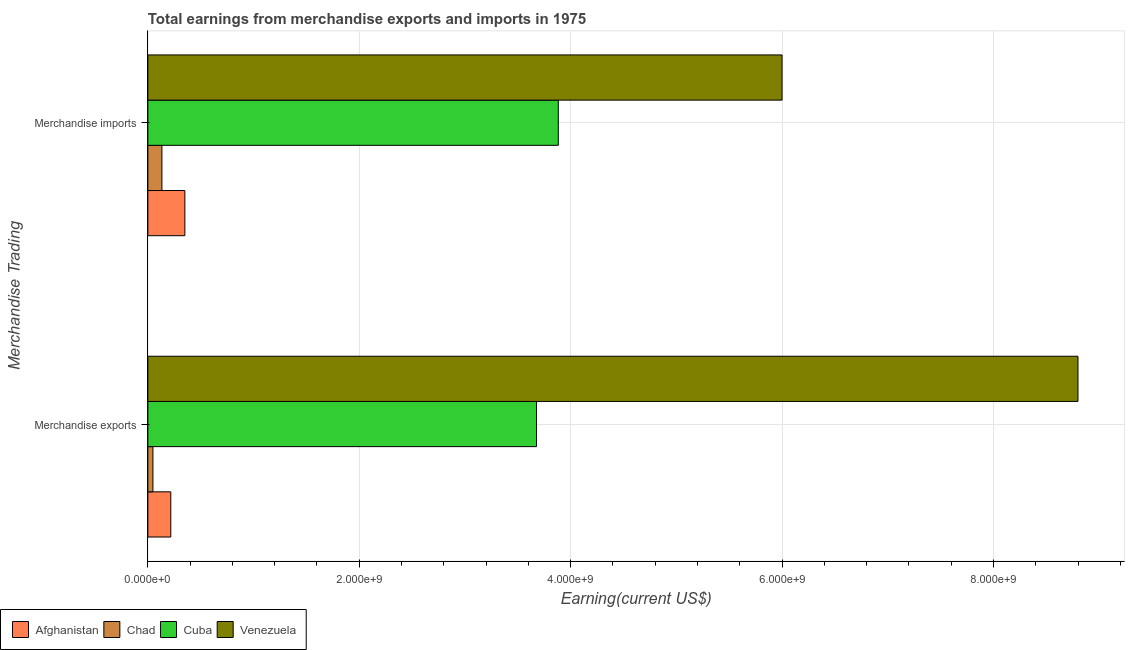Are the number of bars per tick equal to the number of legend labels?
Your response must be concise. Yes. What is the label of the 1st group of bars from the top?
Keep it short and to the point. Merchandise imports. What is the earnings from merchandise imports in Chad?
Provide a succinct answer. 1.33e+08. Across all countries, what is the maximum earnings from merchandise imports?
Your response must be concise. 6.00e+09. Across all countries, what is the minimum earnings from merchandise exports?
Your response must be concise. 4.78e+07. In which country was the earnings from merchandise imports maximum?
Give a very brief answer. Venezuela. In which country was the earnings from merchandise exports minimum?
Offer a terse response. Chad. What is the total earnings from merchandise imports in the graph?
Provide a succinct answer. 1.04e+1. What is the difference between the earnings from merchandise imports in Afghanistan and that in Cuba?
Give a very brief answer. -3.53e+09. What is the difference between the earnings from merchandise exports in Afghanistan and the earnings from merchandise imports in Cuba?
Provide a short and direct response. -3.67e+09. What is the average earnings from merchandise imports per country?
Offer a terse response. 2.59e+09. What is the difference between the earnings from merchandise imports and earnings from merchandise exports in Venezuela?
Your response must be concise. -2.80e+09. In how many countries, is the earnings from merchandise imports greater than 1600000000 US$?
Ensure brevity in your answer.  2. What is the ratio of the earnings from merchandise imports in Afghanistan to that in Chad?
Offer a terse response. 2.64. Is the earnings from merchandise imports in Venezuela less than that in Afghanistan?
Your response must be concise. No. What does the 1st bar from the top in Merchandise imports represents?
Give a very brief answer. Venezuela. What does the 3rd bar from the bottom in Merchandise imports represents?
Your answer should be very brief. Cuba. How many bars are there?
Keep it short and to the point. 8. Are all the bars in the graph horizontal?
Keep it short and to the point. Yes. Are the values on the major ticks of X-axis written in scientific E-notation?
Offer a very short reply. Yes. Does the graph contain any zero values?
Your answer should be compact. No. Where does the legend appear in the graph?
Offer a very short reply. Bottom left. How are the legend labels stacked?
Make the answer very short. Horizontal. What is the title of the graph?
Ensure brevity in your answer.  Total earnings from merchandise exports and imports in 1975. What is the label or title of the X-axis?
Your response must be concise. Earning(current US$). What is the label or title of the Y-axis?
Your answer should be very brief. Merchandise Trading. What is the Earning(current US$) in Afghanistan in Merchandise exports?
Your response must be concise. 2.17e+08. What is the Earning(current US$) in Chad in Merchandise exports?
Make the answer very short. 4.78e+07. What is the Earning(current US$) in Cuba in Merchandise exports?
Your response must be concise. 3.68e+09. What is the Earning(current US$) of Venezuela in Merchandise exports?
Provide a succinct answer. 8.80e+09. What is the Earning(current US$) in Afghanistan in Merchandise imports?
Your answer should be very brief. 3.50e+08. What is the Earning(current US$) of Chad in Merchandise imports?
Your answer should be very brief. 1.33e+08. What is the Earning(current US$) of Cuba in Merchandise imports?
Your response must be concise. 3.88e+09. What is the Earning(current US$) in Venezuela in Merchandise imports?
Offer a very short reply. 6.00e+09. Across all Merchandise Trading, what is the maximum Earning(current US$) in Afghanistan?
Keep it short and to the point. 3.50e+08. Across all Merchandise Trading, what is the maximum Earning(current US$) in Chad?
Give a very brief answer. 1.33e+08. Across all Merchandise Trading, what is the maximum Earning(current US$) of Cuba?
Offer a very short reply. 3.88e+09. Across all Merchandise Trading, what is the maximum Earning(current US$) in Venezuela?
Offer a very short reply. 8.80e+09. Across all Merchandise Trading, what is the minimum Earning(current US$) in Afghanistan?
Your answer should be compact. 2.17e+08. Across all Merchandise Trading, what is the minimum Earning(current US$) in Chad?
Provide a succinct answer. 4.78e+07. Across all Merchandise Trading, what is the minimum Earning(current US$) in Cuba?
Ensure brevity in your answer.  3.68e+09. Across all Merchandise Trading, what is the minimum Earning(current US$) of Venezuela?
Ensure brevity in your answer.  6.00e+09. What is the total Earning(current US$) in Afghanistan in the graph?
Offer a terse response. 5.67e+08. What is the total Earning(current US$) of Chad in the graph?
Keep it short and to the point. 1.81e+08. What is the total Earning(current US$) of Cuba in the graph?
Offer a very short reply. 7.56e+09. What is the total Earning(current US$) in Venezuela in the graph?
Your response must be concise. 1.48e+1. What is the difference between the Earning(current US$) of Afghanistan in Merchandise exports and that in Merchandise imports?
Your answer should be very brief. -1.33e+08. What is the difference between the Earning(current US$) in Chad in Merchandise exports and that in Merchandise imports?
Provide a short and direct response. -8.50e+07. What is the difference between the Earning(current US$) in Cuba in Merchandise exports and that in Merchandise imports?
Offer a terse response. -2.06e+08. What is the difference between the Earning(current US$) of Venezuela in Merchandise exports and that in Merchandise imports?
Make the answer very short. 2.80e+09. What is the difference between the Earning(current US$) in Afghanistan in Merchandise exports and the Earning(current US$) in Chad in Merchandise imports?
Keep it short and to the point. 8.42e+07. What is the difference between the Earning(current US$) of Afghanistan in Merchandise exports and the Earning(current US$) of Cuba in Merchandise imports?
Give a very brief answer. -3.67e+09. What is the difference between the Earning(current US$) in Afghanistan in Merchandise exports and the Earning(current US$) in Venezuela in Merchandise imports?
Your answer should be compact. -5.78e+09. What is the difference between the Earning(current US$) of Chad in Merchandise exports and the Earning(current US$) of Cuba in Merchandise imports?
Offer a terse response. -3.84e+09. What is the difference between the Earning(current US$) of Chad in Merchandise exports and the Earning(current US$) of Venezuela in Merchandise imports?
Keep it short and to the point. -5.95e+09. What is the difference between the Earning(current US$) of Cuba in Merchandise exports and the Earning(current US$) of Venezuela in Merchandise imports?
Provide a short and direct response. -2.32e+09. What is the average Earning(current US$) in Afghanistan per Merchandise Trading?
Your response must be concise. 2.84e+08. What is the average Earning(current US$) of Chad per Merchandise Trading?
Offer a terse response. 9.03e+07. What is the average Earning(current US$) in Cuba per Merchandise Trading?
Make the answer very short. 3.78e+09. What is the average Earning(current US$) in Venezuela per Merchandise Trading?
Give a very brief answer. 7.40e+09. What is the difference between the Earning(current US$) of Afghanistan and Earning(current US$) of Chad in Merchandise exports?
Make the answer very short. 1.69e+08. What is the difference between the Earning(current US$) in Afghanistan and Earning(current US$) in Cuba in Merchandise exports?
Your response must be concise. -3.46e+09. What is the difference between the Earning(current US$) of Afghanistan and Earning(current US$) of Venezuela in Merchandise exports?
Give a very brief answer. -8.58e+09. What is the difference between the Earning(current US$) of Chad and Earning(current US$) of Cuba in Merchandise exports?
Your answer should be compact. -3.63e+09. What is the difference between the Earning(current US$) of Chad and Earning(current US$) of Venezuela in Merchandise exports?
Your answer should be compact. -8.75e+09. What is the difference between the Earning(current US$) in Cuba and Earning(current US$) in Venezuela in Merchandise exports?
Your answer should be very brief. -5.12e+09. What is the difference between the Earning(current US$) of Afghanistan and Earning(current US$) of Chad in Merchandise imports?
Give a very brief answer. 2.17e+08. What is the difference between the Earning(current US$) in Afghanistan and Earning(current US$) in Cuba in Merchandise imports?
Your answer should be compact. -3.53e+09. What is the difference between the Earning(current US$) of Afghanistan and Earning(current US$) of Venezuela in Merchandise imports?
Give a very brief answer. -5.65e+09. What is the difference between the Earning(current US$) in Chad and Earning(current US$) in Cuba in Merchandise imports?
Provide a short and direct response. -3.75e+09. What is the difference between the Earning(current US$) in Chad and Earning(current US$) in Venezuela in Merchandise imports?
Make the answer very short. -5.87e+09. What is the difference between the Earning(current US$) in Cuba and Earning(current US$) in Venezuela in Merchandise imports?
Keep it short and to the point. -2.12e+09. What is the ratio of the Earning(current US$) of Afghanistan in Merchandise exports to that in Merchandise imports?
Give a very brief answer. 0.62. What is the ratio of the Earning(current US$) of Chad in Merchandise exports to that in Merchandise imports?
Your answer should be compact. 0.36. What is the ratio of the Earning(current US$) in Cuba in Merchandise exports to that in Merchandise imports?
Your answer should be very brief. 0.95. What is the ratio of the Earning(current US$) of Venezuela in Merchandise exports to that in Merchandise imports?
Your response must be concise. 1.47. What is the difference between the highest and the second highest Earning(current US$) of Afghanistan?
Ensure brevity in your answer.  1.33e+08. What is the difference between the highest and the second highest Earning(current US$) in Chad?
Make the answer very short. 8.50e+07. What is the difference between the highest and the second highest Earning(current US$) of Cuba?
Make the answer very short. 2.06e+08. What is the difference between the highest and the second highest Earning(current US$) in Venezuela?
Your response must be concise. 2.80e+09. What is the difference between the highest and the lowest Earning(current US$) in Afghanistan?
Keep it short and to the point. 1.33e+08. What is the difference between the highest and the lowest Earning(current US$) in Chad?
Provide a succinct answer. 8.50e+07. What is the difference between the highest and the lowest Earning(current US$) in Cuba?
Your answer should be compact. 2.06e+08. What is the difference between the highest and the lowest Earning(current US$) of Venezuela?
Offer a terse response. 2.80e+09. 